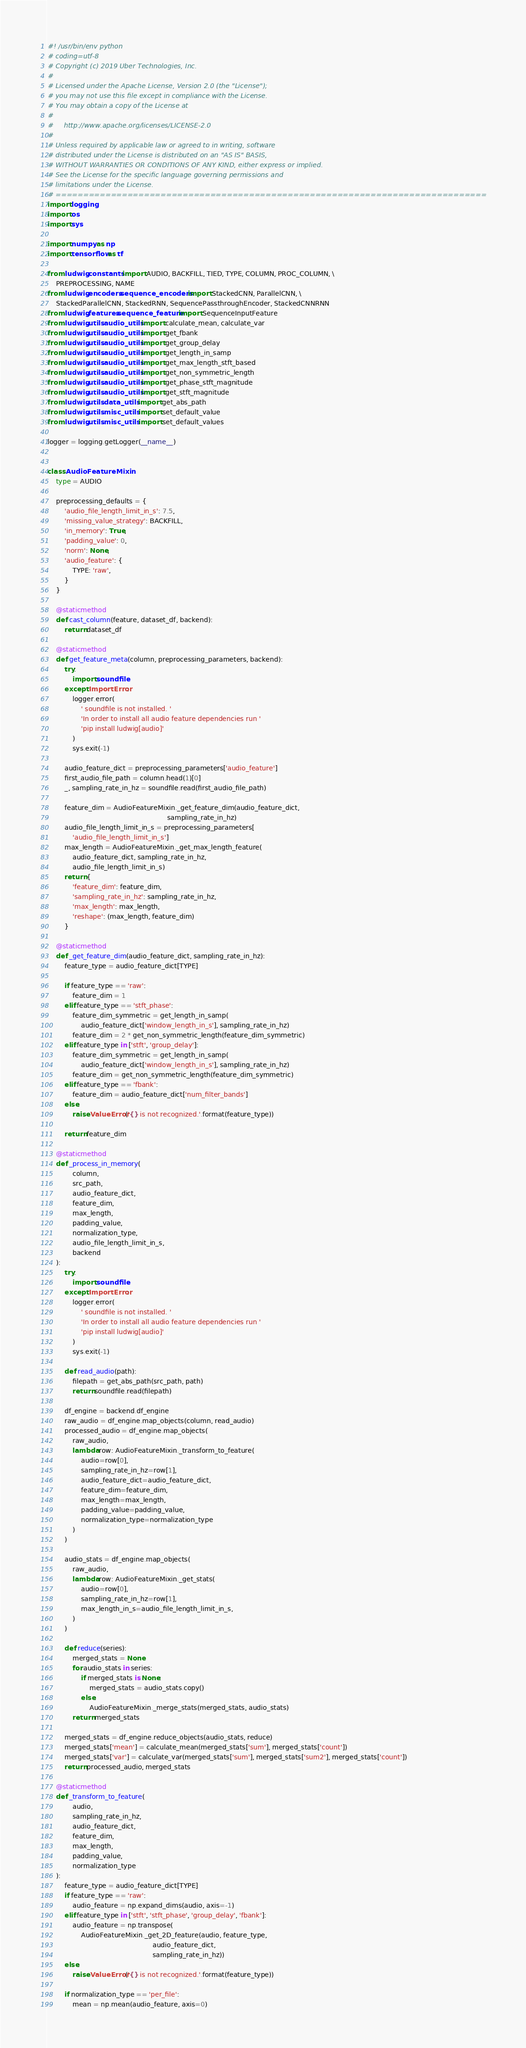Convert code to text. <code><loc_0><loc_0><loc_500><loc_500><_Python_>#! /usr/bin/env python
# coding=utf-8
# Copyright (c) 2019 Uber Technologies, Inc.
#
# Licensed under the Apache License, Version 2.0 (the "License");
# you may not use this file except in compliance with the License.
# You may obtain a copy of the License at
#
#     http://www.apache.org/licenses/LICENSE-2.0
#
# Unless required by applicable law or agreed to in writing, software
# distributed under the License is distributed on an "AS IS" BASIS,
# WITHOUT WARRANTIES OR CONDITIONS OF ANY KIND, either express or implied.
# See the License for the specific language governing permissions and
# limitations under the License.
# ==============================================================================
import logging
import os
import sys

import numpy as np
import tensorflow as tf

from ludwig.constants import AUDIO, BACKFILL, TIED, TYPE, COLUMN, PROC_COLUMN, \
    PREPROCESSING, NAME
from ludwig.encoders.sequence_encoders import StackedCNN, ParallelCNN, \
    StackedParallelCNN, StackedRNN, SequencePassthroughEncoder, StackedCNNRNN
from ludwig.features.sequence_feature import SequenceInputFeature
from ludwig.utils.audio_utils import calculate_mean, calculate_var
from ludwig.utils.audio_utils import get_fbank
from ludwig.utils.audio_utils import get_group_delay
from ludwig.utils.audio_utils import get_length_in_samp
from ludwig.utils.audio_utils import get_max_length_stft_based
from ludwig.utils.audio_utils import get_non_symmetric_length
from ludwig.utils.audio_utils import get_phase_stft_magnitude
from ludwig.utils.audio_utils import get_stft_magnitude
from ludwig.utils.data_utils import get_abs_path
from ludwig.utils.misc_utils import set_default_value
from ludwig.utils.misc_utils import set_default_values

logger = logging.getLogger(__name__)


class AudioFeatureMixin:
    type = AUDIO

    preprocessing_defaults = {
        'audio_file_length_limit_in_s': 7.5,
        'missing_value_strategy': BACKFILL,
        'in_memory': True,
        'padding_value': 0,
        'norm': None,
        'audio_feature': {
            TYPE: 'raw',
        }
    }

    @staticmethod
    def cast_column(feature, dataset_df, backend):
        return dataset_df

    @staticmethod
    def get_feature_meta(column, preprocessing_parameters, backend):
        try:
            import soundfile
        except ImportError:
            logger.error(
                ' soundfile is not installed. '
                'In order to install all audio feature dependencies run '
                'pip install ludwig[audio]'
            )
            sys.exit(-1)

        audio_feature_dict = preprocessing_parameters['audio_feature']
        first_audio_file_path = column.head(1)[0]
        _, sampling_rate_in_hz = soundfile.read(first_audio_file_path)

        feature_dim = AudioFeatureMixin._get_feature_dim(audio_feature_dict,
                                                         sampling_rate_in_hz)
        audio_file_length_limit_in_s = preprocessing_parameters[
            'audio_file_length_limit_in_s']
        max_length = AudioFeatureMixin._get_max_length_feature(
            audio_feature_dict, sampling_rate_in_hz,
            audio_file_length_limit_in_s)
        return {
            'feature_dim': feature_dim,
            'sampling_rate_in_hz': sampling_rate_in_hz,
            'max_length': max_length,
            'reshape': (max_length, feature_dim)
        }

    @staticmethod
    def _get_feature_dim(audio_feature_dict, sampling_rate_in_hz):
        feature_type = audio_feature_dict[TYPE]

        if feature_type == 'raw':
            feature_dim = 1
        elif feature_type == 'stft_phase':
            feature_dim_symmetric = get_length_in_samp(
                audio_feature_dict['window_length_in_s'], sampling_rate_in_hz)
            feature_dim = 2 * get_non_symmetric_length(feature_dim_symmetric)
        elif feature_type in ['stft', 'group_delay']:
            feature_dim_symmetric = get_length_in_samp(
                audio_feature_dict['window_length_in_s'], sampling_rate_in_hz)
            feature_dim = get_non_symmetric_length(feature_dim_symmetric)
        elif feature_type == 'fbank':
            feature_dim = audio_feature_dict['num_filter_bands']
        else:
            raise ValueError('{} is not recognized.'.format(feature_type))

        return feature_dim

    @staticmethod
    def _process_in_memory(
            column,
            src_path,
            audio_feature_dict,
            feature_dim,
            max_length,
            padding_value,
            normalization_type,
            audio_file_length_limit_in_s,
            backend
    ):
        try:
            import soundfile
        except ImportError:
            logger.error(
                ' soundfile is not installed. '
                'In order to install all audio feature dependencies run '
                'pip install ludwig[audio]'
            )
            sys.exit(-1)

        def read_audio(path):
            filepath = get_abs_path(src_path, path)
            return soundfile.read(filepath)

        df_engine = backend.df_engine
        raw_audio = df_engine.map_objects(column, read_audio)
        processed_audio = df_engine.map_objects(
            raw_audio,
            lambda row: AudioFeatureMixin._transform_to_feature(
                audio=row[0],
                sampling_rate_in_hz=row[1],
                audio_feature_dict=audio_feature_dict,
                feature_dim=feature_dim,
                max_length=max_length,
                padding_value=padding_value,
                normalization_type=normalization_type
            )
        )

        audio_stats = df_engine.map_objects(
            raw_audio,
            lambda row: AudioFeatureMixin._get_stats(
                audio=row[0],
                sampling_rate_in_hz=row[1],
                max_length_in_s=audio_file_length_limit_in_s,
            )
        )

        def reduce(series):
            merged_stats = None
            for audio_stats in series:
                if merged_stats is None:
                    merged_stats = audio_stats.copy()
                else:
                    AudioFeatureMixin._merge_stats(merged_stats, audio_stats)
            return merged_stats

        merged_stats = df_engine.reduce_objects(audio_stats, reduce)
        merged_stats['mean'] = calculate_mean(merged_stats['sum'], merged_stats['count'])
        merged_stats['var'] = calculate_var(merged_stats['sum'], merged_stats['sum2'], merged_stats['count'])
        return processed_audio, merged_stats

    @staticmethod
    def _transform_to_feature(
            audio,
            sampling_rate_in_hz,
            audio_feature_dict,
            feature_dim,
            max_length,
            padding_value,
            normalization_type
    ):
        feature_type = audio_feature_dict[TYPE]
        if feature_type == 'raw':
            audio_feature = np.expand_dims(audio, axis=-1)
        elif feature_type in ['stft', 'stft_phase', 'group_delay', 'fbank']:
            audio_feature = np.transpose(
                AudioFeatureMixin._get_2D_feature(audio, feature_type,
                                                  audio_feature_dict,
                                                  sampling_rate_in_hz))
        else:
            raise ValueError('{} is not recognized.'.format(feature_type))

        if normalization_type == 'per_file':
            mean = np.mean(audio_feature, axis=0)</code> 